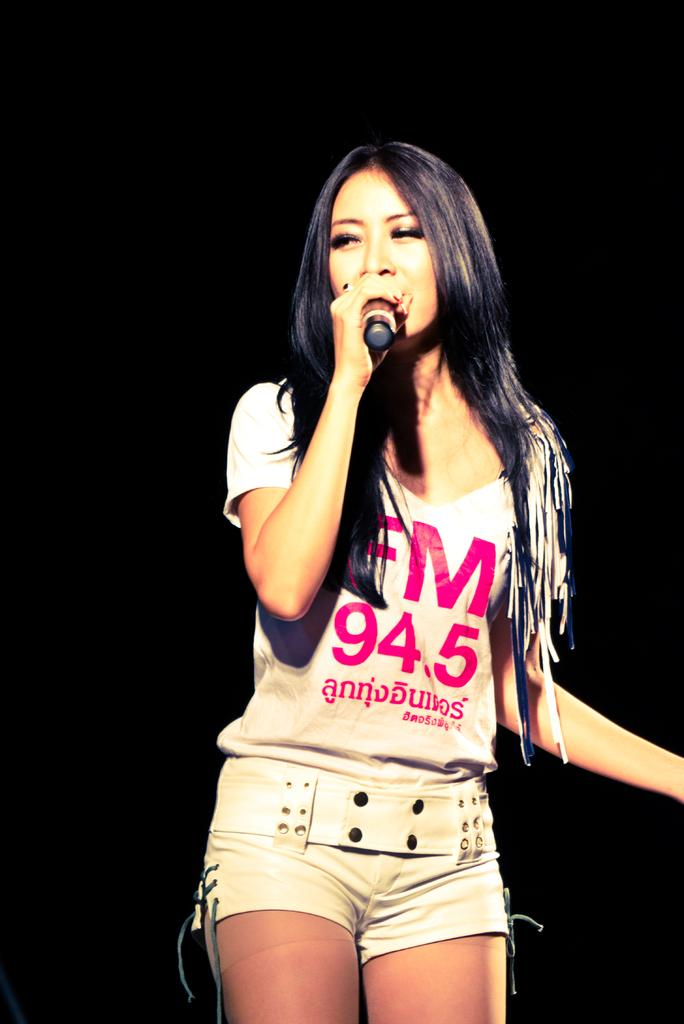Who is the main subject in the image? There is a girl in the image. What is the girl holding in the image? The girl is holding a microphone. What type of clothing is the girl wearing? The girl is wearing shorts. What type of cart is the girl using to transport her belongings in the image? There is no cart present in the image; the girl is holding a microphone and wearing shorts. 